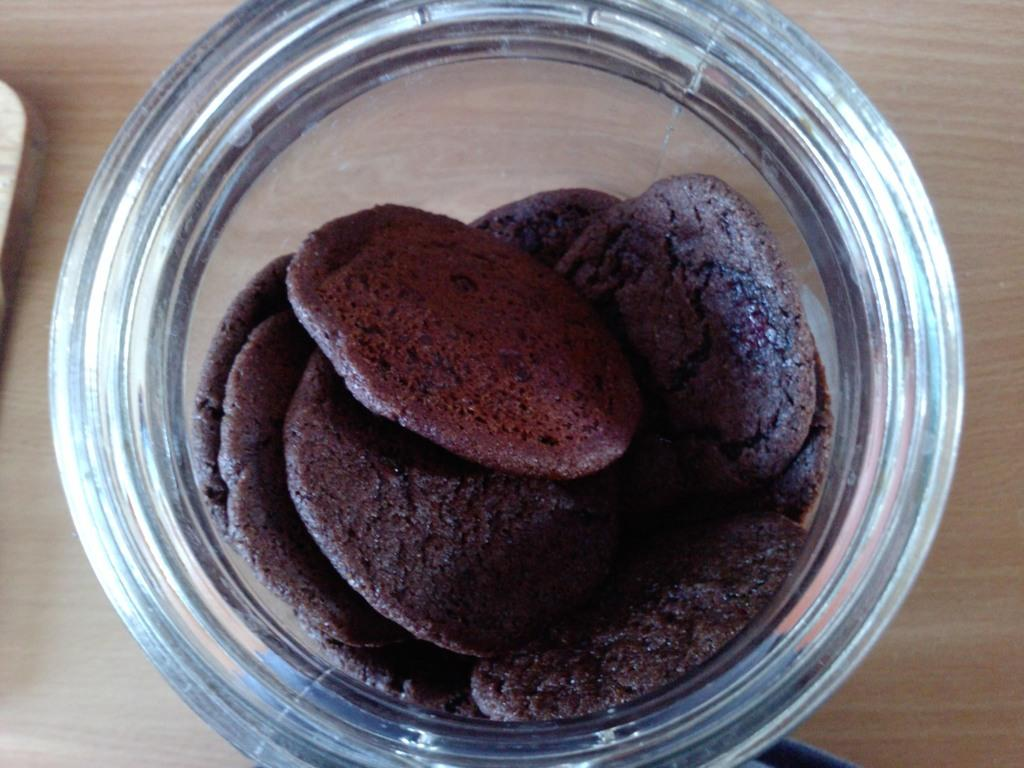What type of items can be seen in the image? There are food items in the image. How are the food items contained in the image? The food items are placed in a jar. What is the jar resting on in the image? The jar is placed on a wooden object. What type of doctor is examining the jar in the image? There is no doctor present in the image, and the jar is not being examined by anyone. 